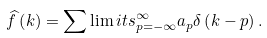<formula> <loc_0><loc_0><loc_500><loc_500>\widehat { f } \left ( k \right ) = \sum \lim i t s _ { p = - \infty } ^ { \infty } a _ { p } \delta \left ( k - p \right ) .</formula> 